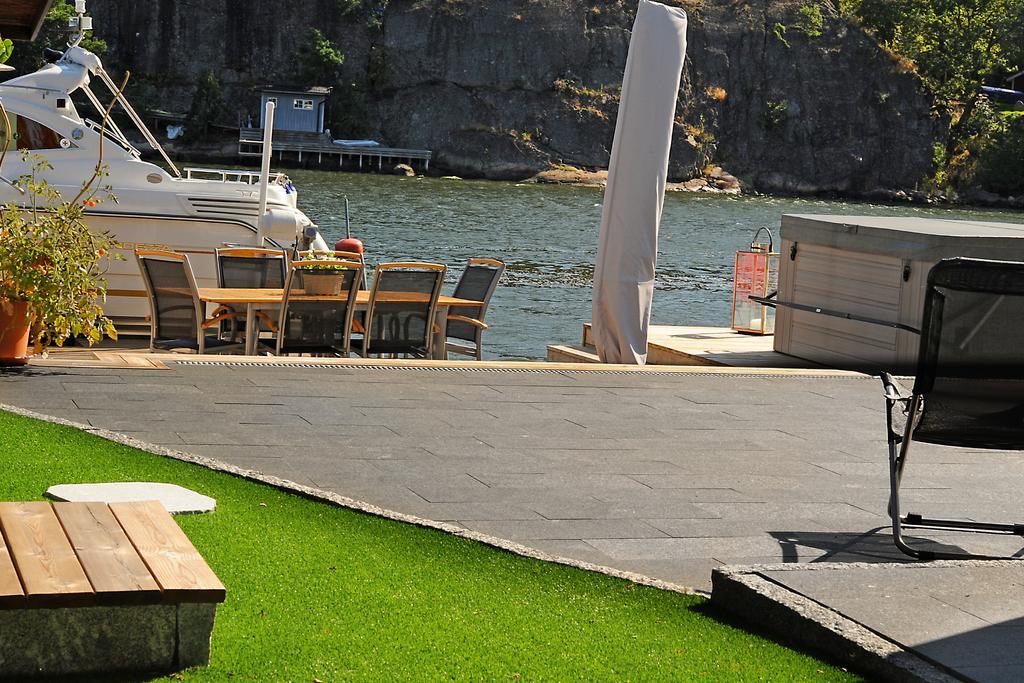Could you give a brief overview of what you see in this image? In this picture, we can see on the path there are chairs, table and on the table there is a pot with plant and grass. Behind the chairs there's a boat on the water, trees and a hill. 